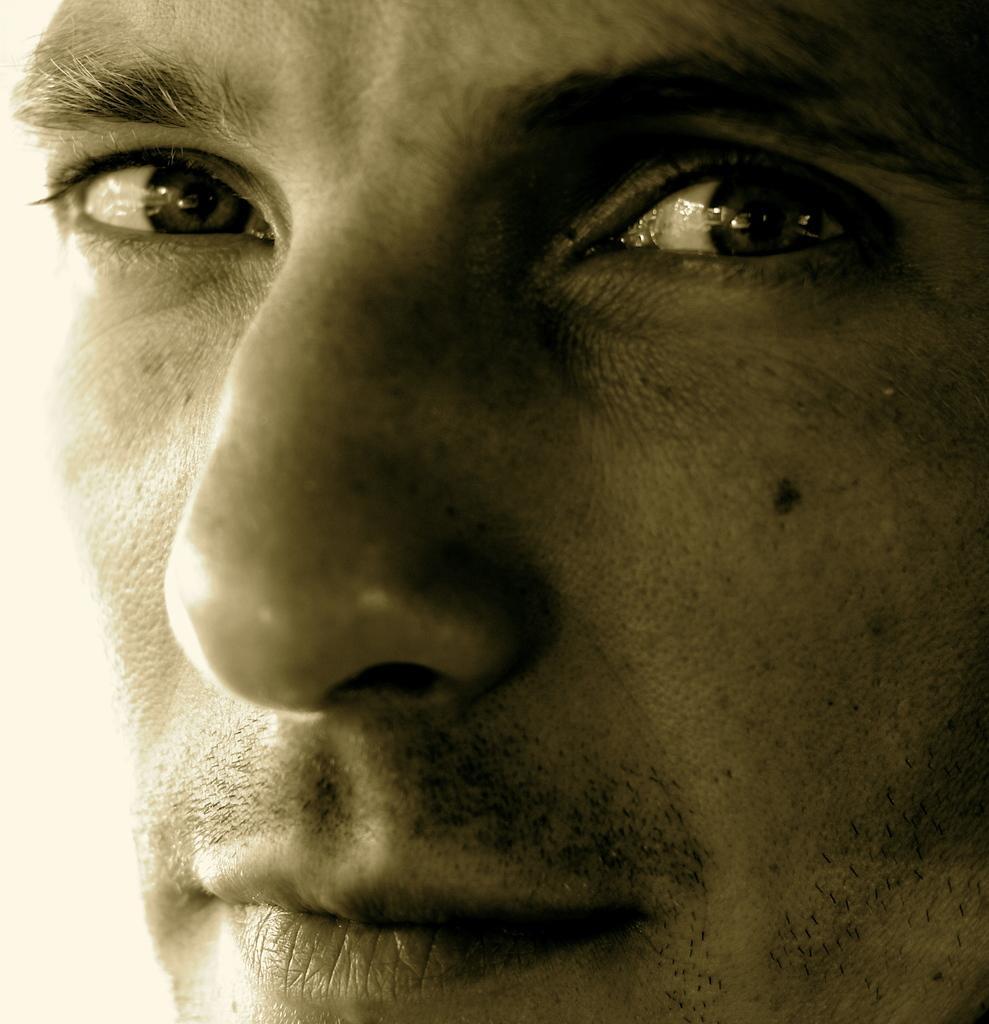Describe this image in one or two sentences. In this image we can see a person's face. 